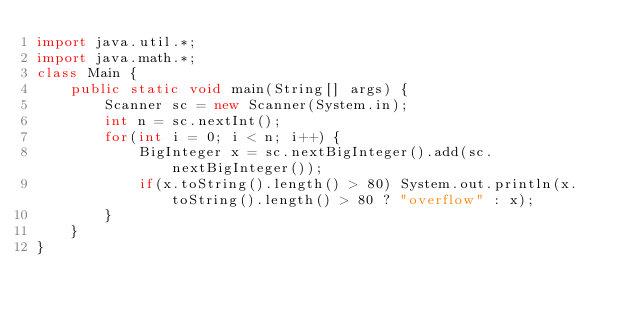<code> <loc_0><loc_0><loc_500><loc_500><_Java_>import java.util.*;
import java.math.*;
class Main {
	public static void main(String[] args) {
		Scanner sc = new Scanner(System.in);
		int n = sc.nextInt();
		for(int i = 0; i < n; i++) {
			BigInteger x = sc.nextBigInteger().add(sc.nextBigInteger());
			if(x.toString().length() > 80) System.out.println(x.toString().length() > 80 ? "overflow" : x);
		}
	}
}</code> 